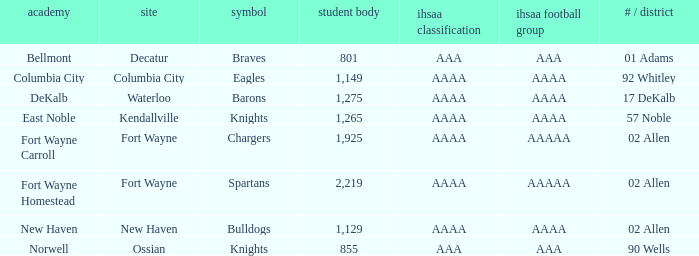What's the IHSAA Football Class in Decatur with an AAA IHSAA class? AAA. 